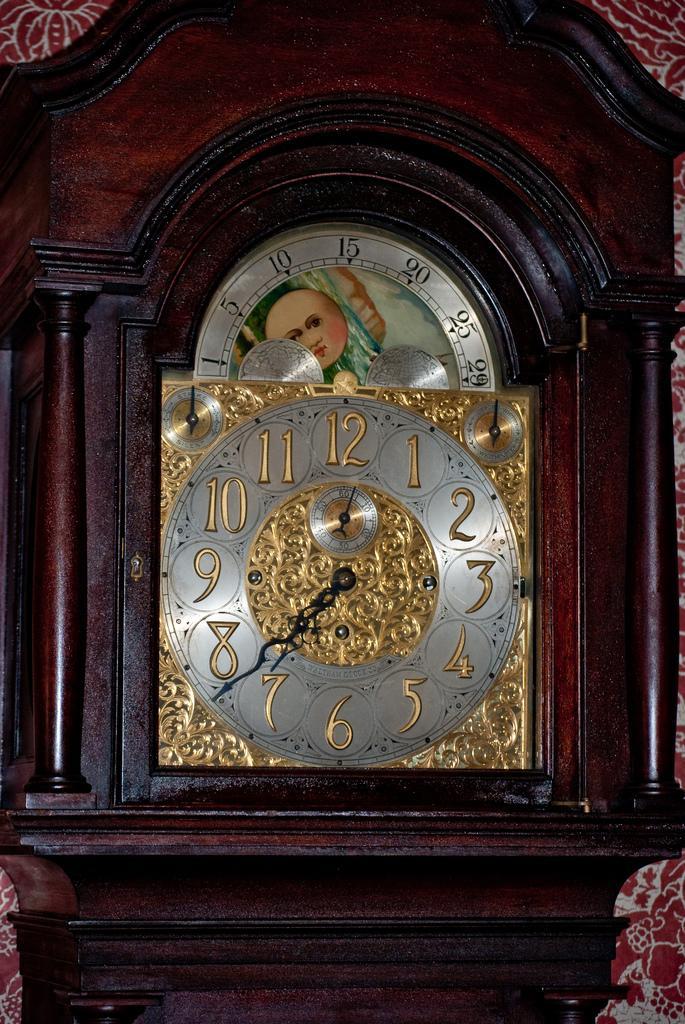How would you summarize this image in a sentence or two? In this picture we can see a wall clock. Background there is a designed wall. 